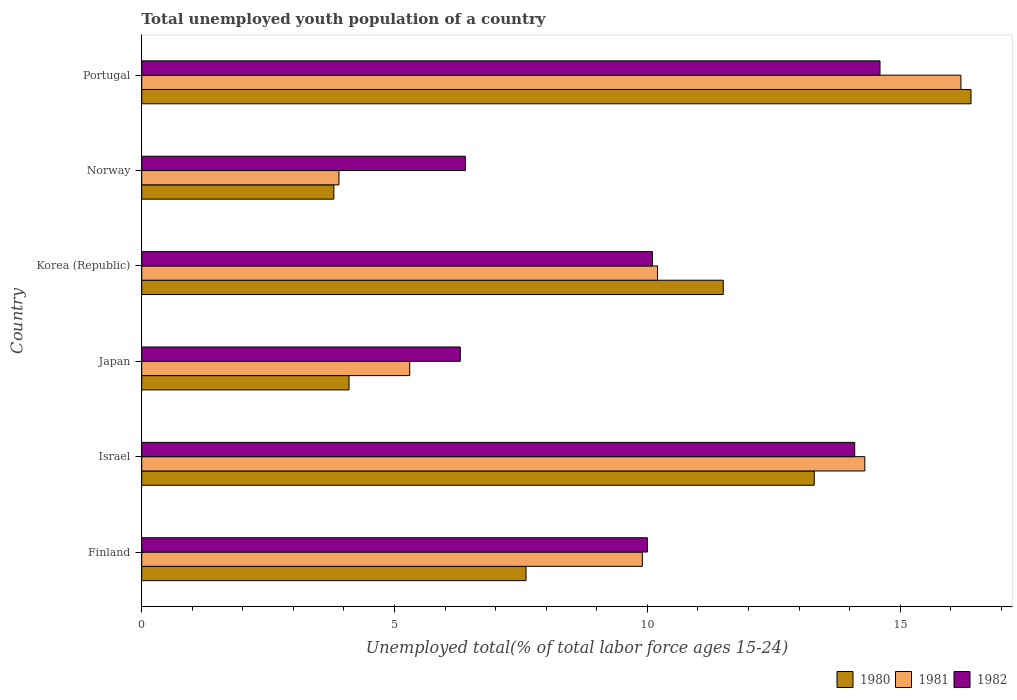How many different coloured bars are there?
Your answer should be compact. 3. How many groups of bars are there?
Your answer should be very brief. 6. Are the number of bars per tick equal to the number of legend labels?
Provide a succinct answer. Yes. Are the number of bars on each tick of the Y-axis equal?
Your answer should be very brief. Yes. How many bars are there on the 6th tick from the bottom?
Give a very brief answer. 3. What is the percentage of total unemployed youth population of a country in 1981 in Finland?
Provide a succinct answer. 9.9. Across all countries, what is the maximum percentage of total unemployed youth population of a country in 1981?
Make the answer very short. 16.2. Across all countries, what is the minimum percentage of total unemployed youth population of a country in 1981?
Your answer should be compact. 3.9. In which country was the percentage of total unemployed youth population of a country in 1982 maximum?
Your answer should be compact. Portugal. In which country was the percentage of total unemployed youth population of a country in 1981 minimum?
Give a very brief answer. Norway. What is the total percentage of total unemployed youth population of a country in 1982 in the graph?
Your response must be concise. 61.5. What is the difference between the percentage of total unemployed youth population of a country in 1982 in Japan and that in Korea (Republic)?
Provide a succinct answer. -3.8. What is the difference between the percentage of total unemployed youth population of a country in 1981 in Japan and the percentage of total unemployed youth population of a country in 1982 in Finland?
Offer a very short reply. -4.7. What is the average percentage of total unemployed youth population of a country in 1980 per country?
Ensure brevity in your answer.  9.45. What is the difference between the percentage of total unemployed youth population of a country in 1980 and percentage of total unemployed youth population of a country in 1982 in Israel?
Offer a terse response. -0.8. In how many countries, is the percentage of total unemployed youth population of a country in 1980 greater than 7 %?
Keep it short and to the point. 4. What is the ratio of the percentage of total unemployed youth population of a country in 1980 in Finland to that in Portugal?
Your answer should be compact. 0.46. What is the difference between the highest and the second highest percentage of total unemployed youth population of a country in 1980?
Provide a short and direct response. 3.1. What is the difference between the highest and the lowest percentage of total unemployed youth population of a country in 1981?
Provide a succinct answer. 12.3. Is the sum of the percentage of total unemployed youth population of a country in 1981 in Israel and Norway greater than the maximum percentage of total unemployed youth population of a country in 1982 across all countries?
Keep it short and to the point. Yes. What does the 2nd bar from the top in Finland represents?
Offer a very short reply. 1981. Is it the case that in every country, the sum of the percentage of total unemployed youth population of a country in 1980 and percentage of total unemployed youth population of a country in 1981 is greater than the percentage of total unemployed youth population of a country in 1982?
Provide a short and direct response. Yes. Are all the bars in the graph horizontal?
Give a very brief answer. Yes. How many countries are there in the graph?
Make the answer very short. 6. How are the legend labels stacked?
Provide a succinct answer. Horizontal. What is the title of the graph?
Provide a succinct answer. Total unemployed youth population of a country. Does "2005" appear as one of the legend labels in the graph?
Give a very brief answer. No. What is the label or title of the X-axis?
Keep it short and to the point. Unemployed total(% of total labor force ages 15-24). What is the Unemployed total(% of total labor force ages 15-24) of 1980 in Finland?
Your answer should be compact. 7.6. What is the Unemployed total(% of total labor force ages 15-24) of 1981 in Finland?
Provide a short and direct response. 9.9. What is the Unemployed total(% of total labor force ages 15-24) of 1982 in Finland?
Your answer should be compact. 10. What is the Unemployed total(% of total labor force ages 15-24) of 1980 in Israel?
Give a very brief answer. 13.3. What is the Unemployed total(% of total labor force ages 15-24) of 1981 in Israel?
Keep it short and to the point. 14.3. What is the Unemployed total(% of total labor force ages 15-24) in 1982 in Israel?
Keep it short and to the point. 14.1. What is the Unemployed total(% of total labor force ages 15-24) of 1980 in Japan?
Offer a very short reply. 4.1. What is the Unemployed total(% of total labor force ages 15-24) in 1981 in Japan?
Offer a very short reply. 5.3. What is the Unemployed total(% of total labor force ages 15-24) of 1982 in Japan?
Keep it short and to the point. 6.3. What is the Unemployed total(% of total labor force ages 15-24) in 1980 in Korea (Republic)?
Provide a short and direct response. 11.5. What is the Unemployed total(% of total labor force ages 15-24) of 1981 in Korea (Republic)?
Your answer should be compact. 10.2. What is the Unemployed total(% of total labor force ages 15-24) of 1982 in Korea (Republic)?
Your response must be concise. 10.1. What is the Unemployed total(% of total labor force ages 15-24) of 1980 in Norway?
Provide a short and direct response. 3.8. What is the Unemployed total(% of total labor force ages 15-24) of 1981 in Norway?
Offer a terse response. 3.9. What is the Unemployed total(% of total labor force ages 15-24) of 1982 in Norway?
Offer a terse response. 6.4. What is the Unemployed total(% of total labor force ages 15-24) in 1980 in Portugal?
Provide a succinct answer. 16.4. What is the Unemployed total(% of total labor force ages 15-24) in 1981 in Portugal?
Provide a succinct answer. 16.2. What is the Unemployed total(% of total labor force ages 15-24) in 1982 in Portugal?
Your answer should be compact. 14.6. Across all countries, what is the maximum Unemployed total(% of total labor force ages 15-24) of 1980?
Offer a very short reply. 16.4. Across all countries, what is the maximum Unemployed total(% of total labor force ages 15-24) in 1981?
Make the answer very short. 16.2. Across all countries, what is the maximum Unemployed total(% of total labor force ages 15-24) of 1982?
Offer a terse response. 14.6. Across all countries, what is the minimum Unemployed total(% of total labor force ages 15-24) in 1980?
Make the answer very short. 3.8. Across all countries, what is the minimum Unemployed total(% of total labor force ages 15-24) of 1981?
Offer a terse response. 3.9. Across all countries, what is the minimum Unemployed total(% of total labor force ages 15-24) of 1982?
Keep it short and to the point. 6.3. What is the total Unemployed total(% of total labor force ages 15-24) of 1980 in the graph?
Offer a terse response. 56.7. What is the total Unemployed total(% of total labor force ages 15-24) in 1981 in the graph?
Ensure brevity in your answer.  59.8. What is the total Unemployed total(% of total labor force ages 15-24) of 1982 in the graph?
Offer a terse response. 61.5. What is the difference between the Unemployed total(% of total labor force ages 15-24) of 1982 in Finland and that in Israel?
Ensure brevity in your answer.  -4.1. What is the difference between the Unemployed total(% of total labor force ages 15-24) in 1982 in Finland and that in Korea (Republic)?
Provide a succinct answer. -0.1. What is the difference between the Unemployed total(% of total labor force ages 15-24) of 1981 in Finland and that in Norway?
Keep it short and to the point. 6. What is the difference between the Unemployed total(% of total labor force ages 15-24) in 1982 in Finland and that in Norway?
Your answer should be very brief. 3.6. What is the difference between the Unemployed total(% of total labor force ages 15-24) in 1980 in Finland and that in Portugal?
Give a very brief answer. -8.8. What is the difference between the Unemployed total(% of total labor force ages 15-24) in 1980 in Israel and that in Japan?
Your answer should be compact. 9.2. What is the difference between the Unemployed total(% of total labor force ages 15-24) in 1982 in Israel and that in Japan?
Provide a succinct answer. 7.8. What is the difference between the Unemployed total(% of total labor force ages 15-24) in 1980 in Israel and that in Korea (Republic)?
Ensure brevity in your answer.  1.8. What is the difference between the Unemployed total(% of total labor force ages 15-24) of 1981 in Israel and that in Korea (Republic)?
Provide a short and direct response. 4.1. What is the difference between the Unemployed total(% of total labor force ages 15-24) in 1980 in Israel and that in Norway?
Offer a terse response. 9.5. What is the difference between the Unemployed total(% of total labor force ages 15-24) of 1981 in Israel and that in Portugal?
Your answer should be compact. -1.9. What is the difference between the Unemployed total(% of total labor force ages 15-24) of 1982 in Israel and that in Portugal?
Offer a terse response. -0.5. What is the difference between the Unemployed total(% of total labor force ages 15-24) of 1981 in Japan and that in Norway?
Your response must be concise. 1.4. What is the difference between the Unemployed total(% of total labor force ages 15-24) in 1982 in Japan and that in Norway?
Give a very brief answer. -0.1. What is the difference between the Unemployed total(% of total labor force ages 15-24) in 1980 in Japan and that in Portugal?
Your answer should be compact. -12.3. What is the difference between the Unemployed total(% of total labor force ages 15-24) in 1981 in Japan and that in Portugal?
Keep it short and to the point. -10.9. What is the difference between the Unemployed total(% of total labor force ages 15-24) in 1981 in Korea (Republic) and that in Portugal?
Your answer should be very brief. -6. What is the difference between the Unemployed total(% of total labor force ages 15-24) of 1980 in Finland and the Unemployed total(% of total labor force ages 15-24) of 1981 in Israel?
Your answer should be compact. -6.7. What is the difference between the Unemployed total(% of total labor force ages 15-24) in 1981 in Finland and the Unemployed total(% of total labor force ages 15-24) in 1982 in Israel?
Provide a succinct answer. -4.2. What is the difference between the Unemployed total(% of total labor force ages 15-24) in 1980 in Finland and the Unemployed total(% of total labor force ages 15-24) in 1981 in Japan?
Keep it short and to the point. 2.3. What is the difference between the Unemployed total(% of total labor force ages 15-24) in 1980 in Finland and the Unemployed total(% of total labor force ages 15-24) in 1982 in Japan?
Your answer should be very brief. 1.3. What is the difference between the Unemployed total(% of total labor force ages 15-24) of 1980 in Finland and the Unemployed total(% of total labor force ages 15-24) of 1981 in Korea (Republic)?
Provide a succinct answer. -2.6. What is the difference between the Unemployed total(% of total labor force ages 15-24) of 1980 in Finland and the Unemployed total(% of total labor force ages 15-24) of 1981 in Norway?
Offer a very short reply. 3.7. What is the difference between the Unemployed total(% of total labor force ages 15-24) of 1980 in Finland and the Unemployed total(% of total labor force ages 15-24) of 1982 in Norway?
Your answer should be compact. 1.2. What is the difference between the Unemployed total(% of total labor force ages 15-24) of 1981 in Finland and the Unemployed total(% of total labor force ages 15-24) of 1982 in Norway?
Provide a short and direct response. 3.5. What is the difference between the Unemployed total(% of total labor force ages 15-24) of 1980 in Israel and the Unemployed total(% of total labor force ages 15-24) of 1981 in Japan?
Your answer should be very brief. 8. What is the difference between the Unemployed total(% of total labor force ages 15-24) of 1980 in Israel and the Unemployed total(% of total labor force ages 15-24) of 1982 in Japan?
Offer a very short reply. 7. What is the difference between the Unemployed total(% of total labor force ages 15-24) in 1980 in Japan and the Unemployed total(% of total labor force ages 15-24) in 1982 in Korea (Republic)?
Your response must be concise. -6. What is the difference between the Unemployed total(% of total labor force ages 15-24) in 1981 in Japan and the Unemployed total(% of total labor force ages 15-24) in 1982 in Korea (Republic)?
Offer a very short reply. -4.8. What is the difference between the Unemployed total(% of total labor force ages 15-24) in 1980 in Japan and the Unemployed total(% of total labor force ages 15-24) in 1982 in Norway?
Your response must be concise. -2.3. What is the difference between the Unemployed total(% of total labor force ages 15-24) in 1981 in Japan and the Unemployed total(% of total labor force ages 15-24) in 1982 in Portugal?
Make the answer very short. -9.3. What is the difference between the Unemployed total(% of total labor force ages 15-24) of 1980 in Korea (Republic) and the Unemployed total(% of total labor force ages 15-24) of 1982 in Norway?
Offer a very short reply. 5.1. What is the difference between the Unemployed total(% of total labor force ages 15-24) of 1980 in Norway and the Unemployed total(% of total labor force ages 15-24) of 1981 in Portugal?
Your answer should be compact. -12.4. What is the difference between the Unemployed total(% of total labor force ages 15-24) of 1980 in Norway and the Unemployed total(% of total labor force ages 15-24) of 1982 in Portugal?
Provide a short and direct response. -10.8. What is the average Unemployed total(% of total labor force ages 15-24) in 1980 per country?
Make the answer very short. 9.45. What is the average Unemployed total(% of total labor force ages 15-24) in 1981 per country?
Ensure brevity in your answer.  9.97. What is the average Unemployed total(% of total labor force ages 15-24) of 1982 per country?
Your answer should be compact. 10.25. What is the difference between the Unemployed total(% of total labor force ages 15-24) of 1980 and Unemployed total(% of total labor force ages 15-24) of 1981 in Finland?
Your response must be concise. -2.3. What is the difference between the Unemployed total(% of total labor force ages 15-24) of 1981 and Unemployed total(% of total labor force ages 15-24) of 1982 in Finland?
Your answer should be very brief. -0.1. What is the difference between the Unemployed total(% of total labor force ages 15-24) in 1980 and Unemployed total(% of total labor force ages 15-24) in 1981 in Israel?
Offer a very short reply. -1. What is the difference between the Unemployed total(% of total labor force ages 15-24) in 1980 and Unemployed total(% of total labor force ages 15-24) in 1982 in Israel?
Provide a succinct answer. -0.8. What is the difference between the Unemployed total(% of total labor force ages 15-24) of 1980 and Unemployed total(% of total labor force ages 15-24) of 1982 in Japan?
Offer a terse response. -2.2. What is the difference between the Unemployed total(% of total labor force ages 15-24) of 1981 and Unemployed total(% of total labor force ages 15-24) of 1982 in Japan?
Provide a succinct answer. -1. What is the difference between the Unemployed total(% of total labor force ages 15-24) in 1980 and Unemployed total(% of total labor force ages 15-24) in 1981 in Korea (Republic)?
Make the answer very short. 1.3. What is the difference between the Unemployed total(% of total labor force ages 15-24) of 1980 and Unemployed total(% of total labor force ages 15-24) of 1982 in Korea (Republic)?
Your answer should be very brief. 1.4. What is the difference between the Unemployed total(% of total labor force ages 15-24) of 1981 and Unemployed total(% of total labor force ages 15-24) of 1982 in Korea (Republic)?
Give a very brief answer. 0.1. What is the difference between the Unemployed total(% of total labor force ages 15-24) of 1980 and Unemployed total(% of total labor force ages 15-24) of 1982 in Norway?
Give a very brief answer. -2.6. What is the difference between the Unemployed total(% of total labor force ages 15-24) in 1980 and Unemployed total(% of total labor force ages 15-24) in 1982 in Portugal?
Give a very brief answer. 1.8. What is the difference between the Unemployed total(% of total labor force ages 15-24) in 1981 and Unemployed total(% of total labor force ages 15-24) in 1982 in Portugal?
Give a very brief answer. 1.6. What is the ratio of the Unemployed total(% of total labor force ages 15-24) of 1980 in Finland to that in Israel?
Your answer should be very brief. 0.57. What is the ratio of the Unemployed total(% of total labor force ages 15-24) of 1981 in Finland to that in Israel?
Your response must be concise. 0.69. What is the ratio of the Unemployed total(% of total labor force ages 15-24) of 1982 in Finland to that in Israel?
Ensure brevity in your answer.  0.71. What is the ratio of the Unemployed total(% of total labor force ages 15-24) of 1980 in Finland to that in Japan?
Provide a short and direct response. 1.85. What is the ratio of the Unemployed total(% of total labor force ages 15-24) in 1981 in Finland to that in Japan?
Your response must be concise. 1.87. What is the ratio of the Unemployed total(% of total labor force ages 15-24) in 1982 in Finland to that in Japan?
Offer a very short reply. 1.59. What is the ratio of the Unemployed total(% of total labor force ages 15-24) of 1980 in Finland to that in Korea (Republic)?
Keep it short and to the point. 0.66. What is the ratio of the Unemployed total(% of total labor force ages 15-24) in 1981 in Finland to that in Korea (Republic)?
Provide a short and direct response. 0.97. What is the ratio of the Unemployed total(% of total labor force ages 15-24) in 1980 in Finland to that in Norway?
Your answer should be very brief. 2. What is the ratio of the Unemployed total(% of total labor force ages 15-24) of 1981 in Finland to that in Norway?
Your answer should be very brief. 2.54. What is the ratio of the Unemployed total(% of total labor force ages 15-24) in 1982 in Finland to that in Norway?
Ensure brevity in your answer.  1.56. What is the ratio of the Unemployed total(% of total labor force ages 15-24) of 1980 in Finland to that in Portugal?
Offer a terse response. 0.46. What is the ratio of the Unemployed total(% of total labor force ages 15-24) in 1981 in Finland to that in Portugal?
Your answer should be compact. 0.61. What is the ratio of the Unemployed total(% of total labor force ages 15-24) in 1982 in Finland to that in Portugal?
Your answer should be compact. 0.68. What is the ratio of the Unemployed total(% of total labor force ages 15-24) of 1980 in Israel to that in Japan?
Keep it short and to the point. 3.24. What is the ratio of the Unemployed total(% of total labor force ages 15-24) of 1981 in Israel to that in Japan?
Your answer should be very brief. 2.7. What is the ratio of the Unemployed total(% of total labor force ages 15-24) in 1982 in Israel to that in Japan?
Your answer should be compact. 2.24. What is the ratio of the Unemployed total(% of total labor force ages 15-24) in 1980 in Israel to that in Korea (Republic)?
Offer a very short reply. 1.16. What is the ratio of the Unemployed total(% of total labor force ages 15-24) of 1981 in Israel to that in Korea (Republic)?
Keep it short and to the point. 1.4. What is the ratio of the Unemployed total(% of total labor force ages 15-24) of 1982 in Israel to that in Korea (Republic)?
Provide a short and direct response. 1.4. What is the ratio of the Unemployed total(% of total labor force ages 15-24) of 1981 in Israel to that in Norway?
Provide a succinct answer. 3.67. What is the ratio of the Unemployed total(% of total labor force ages 15-24) in 1982 in Israel to that in Norway?
Your response must be concise. 2.2. What is the ratio of the Unemployed total(% of total labor force ages 15-24) of 1980 in Israel to that in Portugal?
Give a very brief answer. 0.81. What is the ratio of the Unemployed total(% of total labor force ages 15-24) in 1981 in Israel to that in Portugal?
Keep it short and to the point. 0.88. What is the ratio of the Unemployed total(% of total labor force ages 15-24) in 1982 in Israel to that in Portugal?
Ensure brevity in your answer.  0.97. What is the ratio of the Unemployed total(% of total labor force ages 15-24) of 1980 in Japan to that in Korea (Republic)?
Your response must be concise. 0.36. What is the ratio of the Unemployed total(% of total labor force ages 15-24) in 1981 in Japan to that in Korea (Republic)?
Your answer should be very brief. 0.52. What is the ratio of the Unemployed total(% of total labor force ages 15-24) in 1982 in Japan to that in Korea (Republic)?
Your answer should be compact. 0.62. What is the ratio of the Unemployed total(% of total labor force ages 15-24) in 1980 in Japan to that in Norway?
Make the answer very short. 1.08. What is the ratio of the Unemployed total(% of total labor force ages 15-24) in 1981 in Japan to that in Norway?
Keep it short and to the point. 1.36. What is the ratio of the Unemployed total(% of total labor force ages 15-24) of 1982 in Japan to that in Norway?
Give a very brief answer. 0.98. What is the ratio of the Unemployed total(% of total labor force ages 15-24) of 1980 in Japan to that in Portugal?
Provide a short and direct response. 0.25. What is the ratio of the Unemployed total(% of total labor force ages 15-24) of 1981 in Japan to that in Portugal?
Provide a succinct answer. 0.33. What is the ratio of the Unemployed total(% of total labor force ages 15-24) of 1982 in Japan to that in Portugal?
Keep it short and to the point. 0.43. What is the ratio of the Unemployed total(% of total labor force ages 15-24) of 1980 in Korea (Republic) to that in Norway?
Keep it short and to the point. 3.03. What is the ratio of the Unemployed total(% of total labor force ages 15-24) in 1981 in Korea (Republic) to that in Norway?
Keep it short and to the point. 2.62. What is the ratio of the Unemployed total(% of total labor force ages 15-24) of 1982 in Korea (Republic) to that in Norway?
Give a very brief answer. 1.58. What is the ratio of the Unemployed total(% of total labor force ages 15-24) of 1980 in Korea (Republic) to that in Portugal?
Your response must be concise. 0.7. What is the ratio of the Unemployed total(% of total labor force ages 15-24) in 1981 in Korea (Republic) to that in Portugal?
Make the answer very short. 0.63. What is the ratio of the Unemployed total(% of total labor force ages 15-24) in 1982 in Korea (Republic) to that in Portugal?
Your response must be concise. 0.69. What is the ratio of the Unemployed total(% of total labor force ages 15-24) in 1980 in Norway to that in Portugal?
Make the answer very short. 0.23. What is the ratio of the Unemployed total(% of total labor force ages 15-24) in 1981 in Norway to that in Portugal?
Your response must be concise. 0.24. What is the ratio of the Unemployed total(% of total labor force ages 15-24) in 1982 in Norway to that in Portugal?
Your response must be concise. 0.44. What is the difference between the highest and the lowest Unemployed total(% of total labor force ages 15-24) of 1980?
Keep it short and to the point. 12.6. What is the difference between the highest and the lowest Unemployed total(% of total labor force ages 15-24) of 1981?
Your response must be concise. 12.3. What is the difference between the highest and the lowest Unemployed total(% of total labor force ages 15-24) in 1982?
Offer a very short reply. 8.3. 